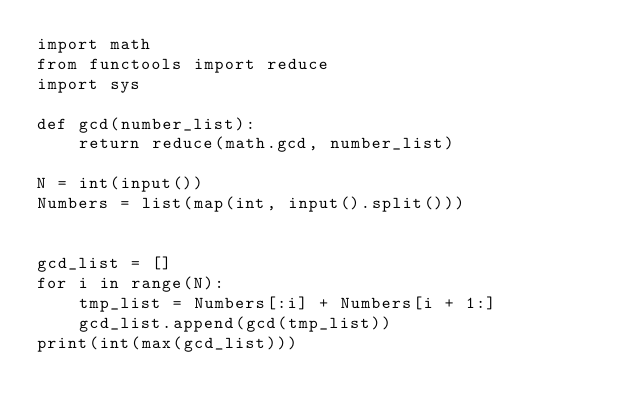<code> <loc_0><loc_0><loc_500><loc_500><_Python_>import math
from functools import reduce
import sys

def gcd(number_list):
    return reduce(math.gcd, number_list)

N = int(input())
Numbers = list(map(int, input().split()))


gcd_list = []
for i in range(N):
    tmp_list = Numbers[:i] + Numbers[i + 1:]
    gcd_list.append(gcd(tmp_list))
print(int(max(gcd_list)))
</code> 